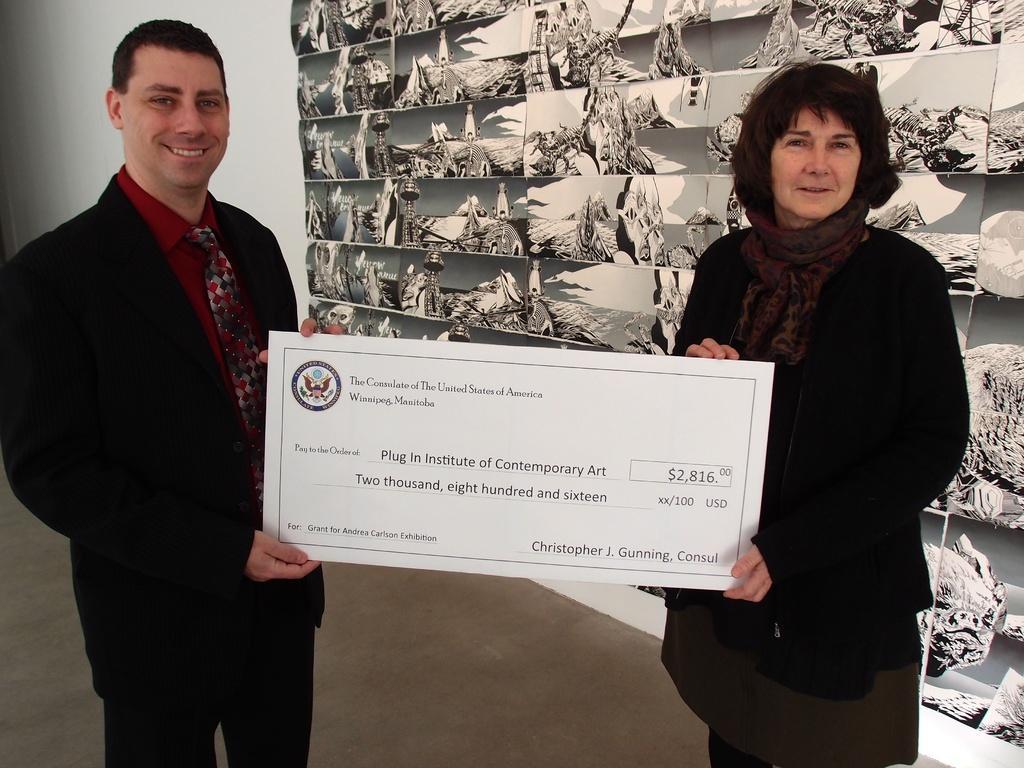Can you describe this image briefly? In this image I can see two people standing and holding white color board and they are wearing different color dress. Back I can see a white wall and different background. 